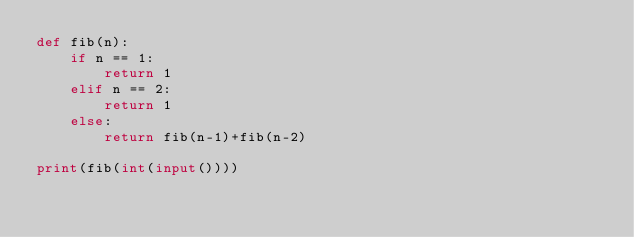Convert code to text. <code><loc_0><loc_0><loc_500><loc_500><_Python_>def fib(n):
    if n == 1:
        return 1
    elif n == 2:
        return 1
    else:
        return fib(n-1)+fib(n-2)

print(fib(int(input())))
</code> 